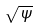Convert formula to latex. <formula><loc_0><loc_0><loc_500><loc_500>\sqrt { \Psi }</formula> 